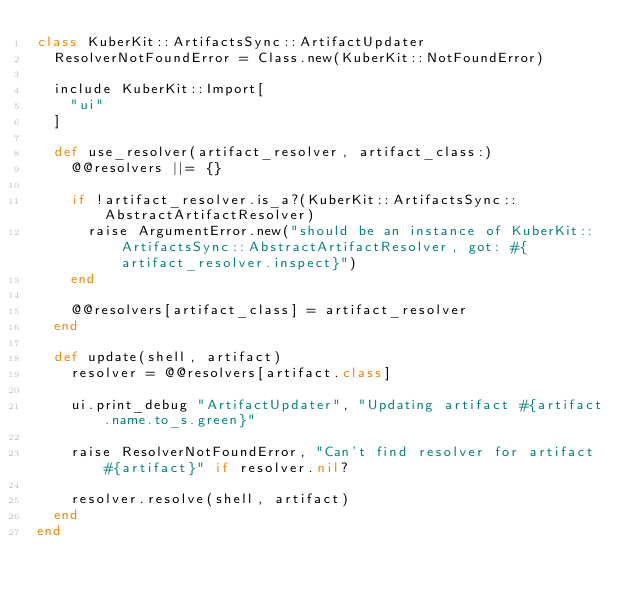<code> <loc_0><loc_0><loc_500><loc_500><_Ruby_>class KuberKit::ArtifactsSync::ArtifactUpdater
  ResolverNotFoundError = Class.new(KuberKit::NotFoundError)

  include KuberKit::Import[
    "ui"
  ]

  def use_resolver(artifact_resolver, artifact_class:)
    @@resolvers ||= {}

    if !artifact_resolver.is_a?(KuberKit::ArtifactsSync::AbstractArtifactResolver)
      raise ArgumentError.new("should be an instance of KuberKit::ArtifactsSync::AbstractArtifactResolver, got: #{artifact_resolver.inspect}")
    end

    @@resolvers[artifact_class] = artifact_resolver
  end

  def update(shell, artifact)
    resolver = @@resolvers[artifact.class]

    ui.print_debug "ArtifactUpdater", "Updating artifact #{artifact.name.to_s.green}"
    
    raise ResolverNotFoundError, "Can't find resolver for artifact #{artifact}" if resolver.nil?

    resolver.resolve(shell, artifact)
  end
end</code> 